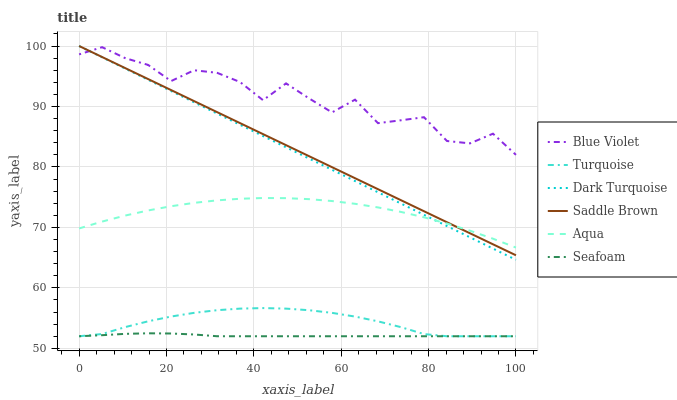Does Seafoam have the minimum area under the curve?
Answer yes or no. Yes. Does Blue Violet have the maximum area under the curve?
Answer yes or no. Yes. Does Dark Turquoise have the minimum area under the curve?
Answer yes or no. No. Does Dark Turquoise have the maximum area under the curve?
Answer yes or no. No. Is Dark Turquoise the smoothest?
Answer yes or no. Yes. Is Blue Violet the roughest?
Answer yes or no. Yes. Is Aqua the smoothest?
Answer yes or no. No. Is Aqua the roughest?
Answer yes or no. No. Does Turquoise have the lowest value?
Answer yes or no. Yes. Does Dark Turquoise have the lowest value?
Answer yes or no. No. Does Saddle Brown have the highest value?
Answer yes or no. Yes. Does Aqua have the highest value?
Answer yes or no. No. Is Seafoam less than Aqua?
Answer yes or no. Yes. Is Aqua greater than Seafoam?
Answer yes or no. Yes. Does Turquoise intersect Seafoam?
Answer yes or no. Yes. Is Turquoise less than Seafoam?
Answer yes or no. No. Is Turquoise greater than Seafoam?
Answer yes or no. No. Does Seafoam intersect Aqua?
Answer yes or no. No. 